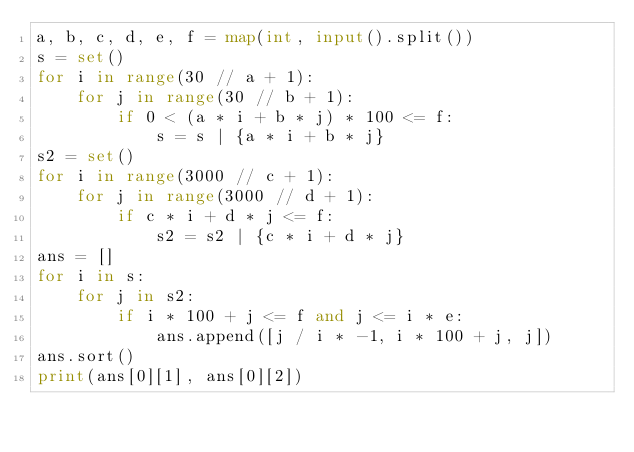<code> <loc_0><loc_0><loc_500><loc_500><_Python_>a, b, c, d, e, f = map(int, input().split())
s = set()
for i in range(30 // a + 1):
    for j in range(30 // b + 1):
        if 0 < (a * i + b * j) * 100 <= f:
            s = s | {a * i + b * j}
s2 = set()
for i in range(3000 // c + 1):
    for j in range(3000 // d + 1):
        if c * i + d * j <= f:
            s2 = s2 | {c * i + d * j}
ans = []
for i in s:
    for j in s2:
        if i * 100 + j <= f and j <= i * e:
            ans.append([j / i * -1, i * 100 + j, j])
ans.sort()
print(ans[0][1], ans[0][2])</code> 